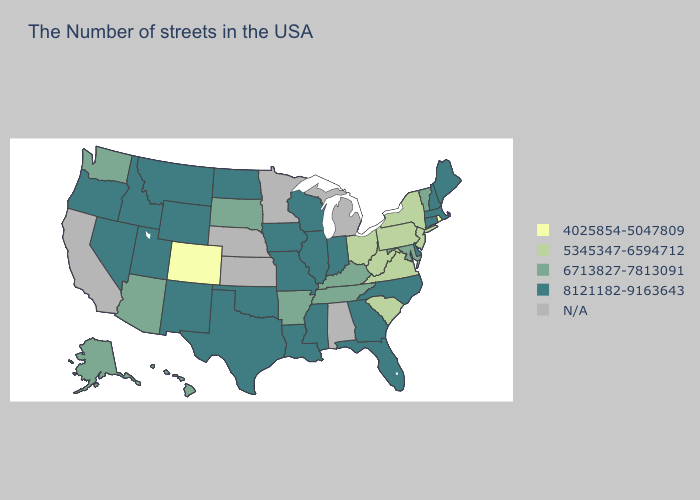What is the value of Georgia?
Give a very brief answer. 8121182-9163643. Does Washington have the highest value in the West?
Give a very brief answer. No. Name the states that have a value in the range 8121182-9163643?
Quick response, please. Maine, Massachusetts, New Hampshire, Connecticut, Delaware, North Carolina, Florida, Georgia, Indiana, Wisconsin, Illinois, Mississippi, Louisiana, Missouri, Iowa, Oklahoma, Texas, North Dakota, Wyoming, New Mexico, Utah, Montana, Idaho, Nevada, Oregon. How many symbols are there in the legend?
Keep it brief. 5. Name the states that have a value in the range N/A?
Be succinct. Michigan, Alabama, Minnesota, Kansas, Nebraska, California. Does Ohio have the highest value in the MidWest?
Short answer required. No. Name the states that have a value in the range 5345347-6594712?
Be succinct. New York, New Jersey, Pennsylvania, Virginia, South Carolina, West Virginia, Ohio. What is the lowest value in the South?
Concise answer only. 5345347-6594712. Among the states that border Arkansas , which have the lowest value?
Concise answer only. Tennessee. Which states have the lowest value in the Northeast?
Short answer required. Rhode Island. Which states hav the highest value in the Northeast?
Concise answer only. Maine, Massachusetts, New Hampshire, Connecticut. Name the states that have a value in the range 8121182-9163643?
Keep it brief. Maine, Massachusetts, New Hampshire, Connecticut, Delaware, North Carolina, Florida, Georgia, Indiana, Wisconsin, Illinois, Mississippi, Louisiana, Missouri, Iowa, Oklahoma, Texas, North Dakota, Wyoming, New Mexico, Utah, Montana, Idaho, Nevada, Oregon. Among the states that border Oregon , does Nevada have the highest value?
Concise answer only. Yes. Does Ohio have the lowest value in the MidWest?
Answer briefly. Yes. 